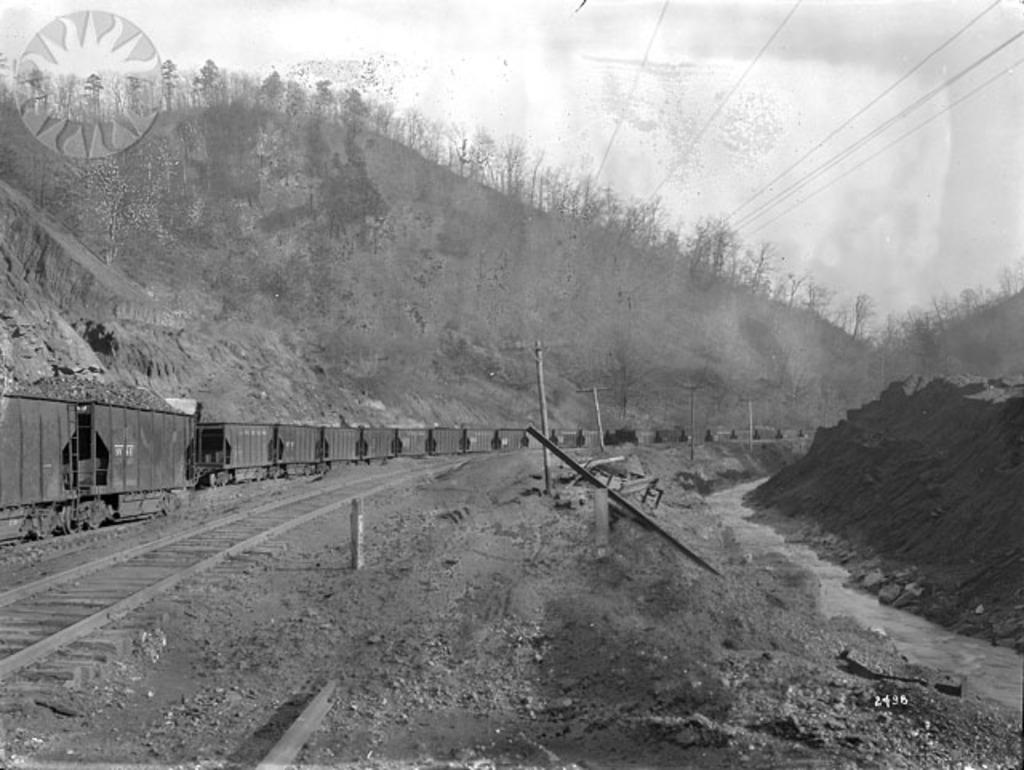What type of landscape can be seen in the image? There is a hill view in the image. What is visible at the top of the image? The sky is visible at the top of the image. What man-made structures can be seen in the image? Power line cables are present in the image. What transportation feature is on the left side of the image? There is a railway track on the left side of the image. Can you see a coach in the stomach of the hill in the image? There is no coach or stomach present in the image; it features a hill view with a railway track and power line cables. Are there any cacti visible on the hill in the image? There are no cacti visible in the image; the hill view consists of natural terrain without any specific plant life mentioned. 